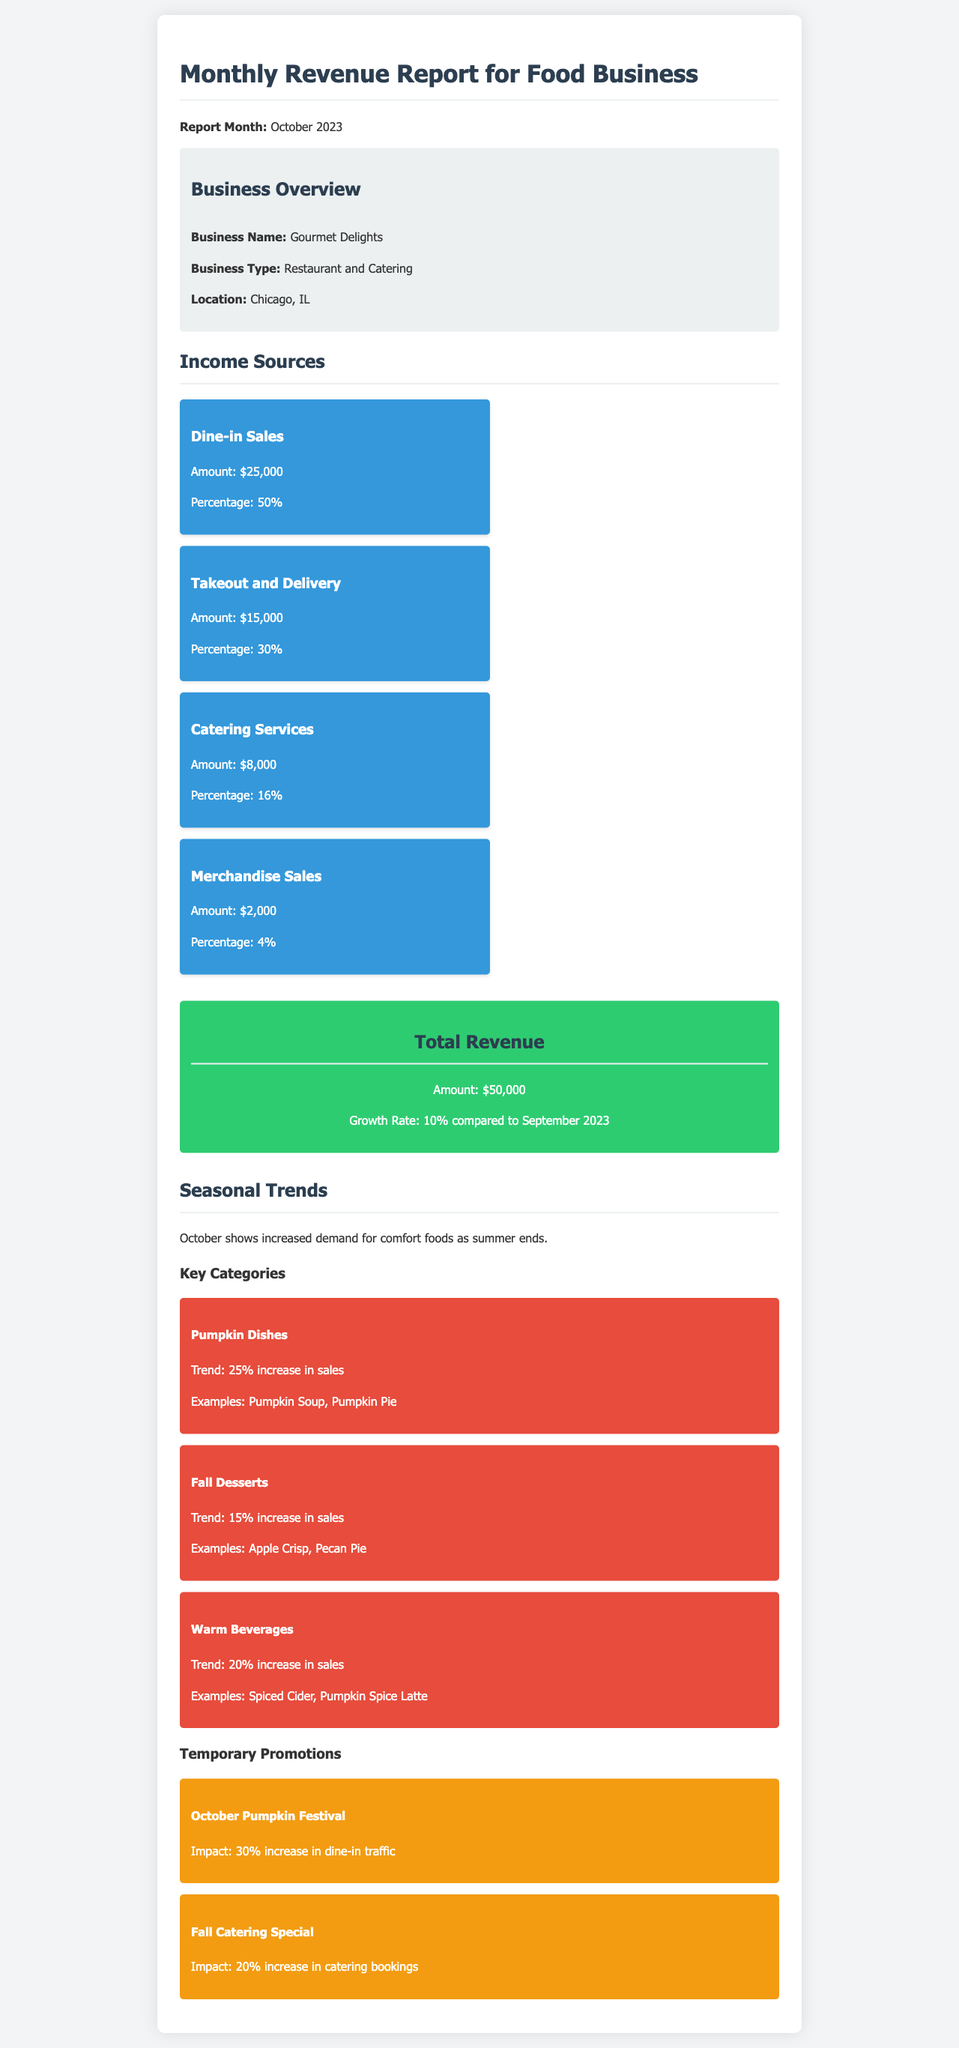what is the report month? The report month is specified in the document heading.
Answer: October 2023 what is the business name? The business name is provided in the business overview section.
Answer: Gourmet Delights what is the total revenue? The total revenue is stated in the total revenue section.
Answer: $50,000 what percentage does Dine-in Sales constitute? The document specifies the percentage share of Dine-in Sales among income sources.
Answer: 50% what is the trend increase for Pumpkin Dishes? The trend increase for Pumpkin Dishes is mentioned in the seasonal trends section.
Answer: 25% increase what impact did the October Pumpkin Festival have on dine-in traffic? The document states the impact of the promotion in terms of increased traffic.
Answer: 30% increase how much revenue was generated from Catering Services? The revenue from Catering Services is detailed under income sources.
Answer: $8,000 which location is specified for the business? The location of the business is noted in the business overview section.
Answer: Chicago, IL what percentage of total revenue growth is reported compared to September 2023? The document states the growth rate compared to the previous month.
Answer: 10% 